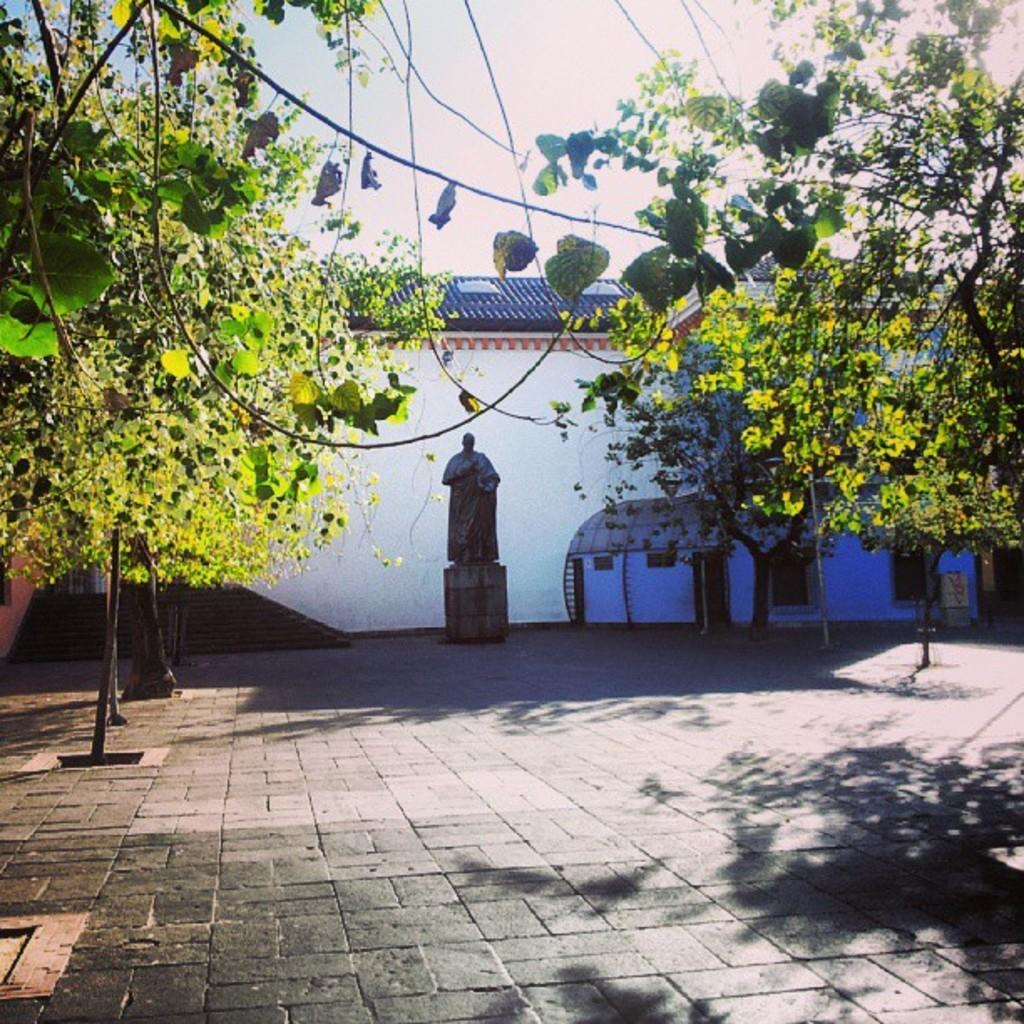What type of vegetation is present on both sides of the floor in the image? There are trees on either side of the floor in the image. What can be seen in the background of the image? There is a building in the background of the image. What is located in the middle of the image? There is a statue in the middle of the image. What is visible above the statue in the image? The sky is visible above the statue. What type of maid is cleaning the statue in the image? There is no maid present in the image, and the statue is not being cleaned. What type of muscle is visible on the statue in the image? The statue does not have any muscles, as it is not a representation of a human or animal body. 